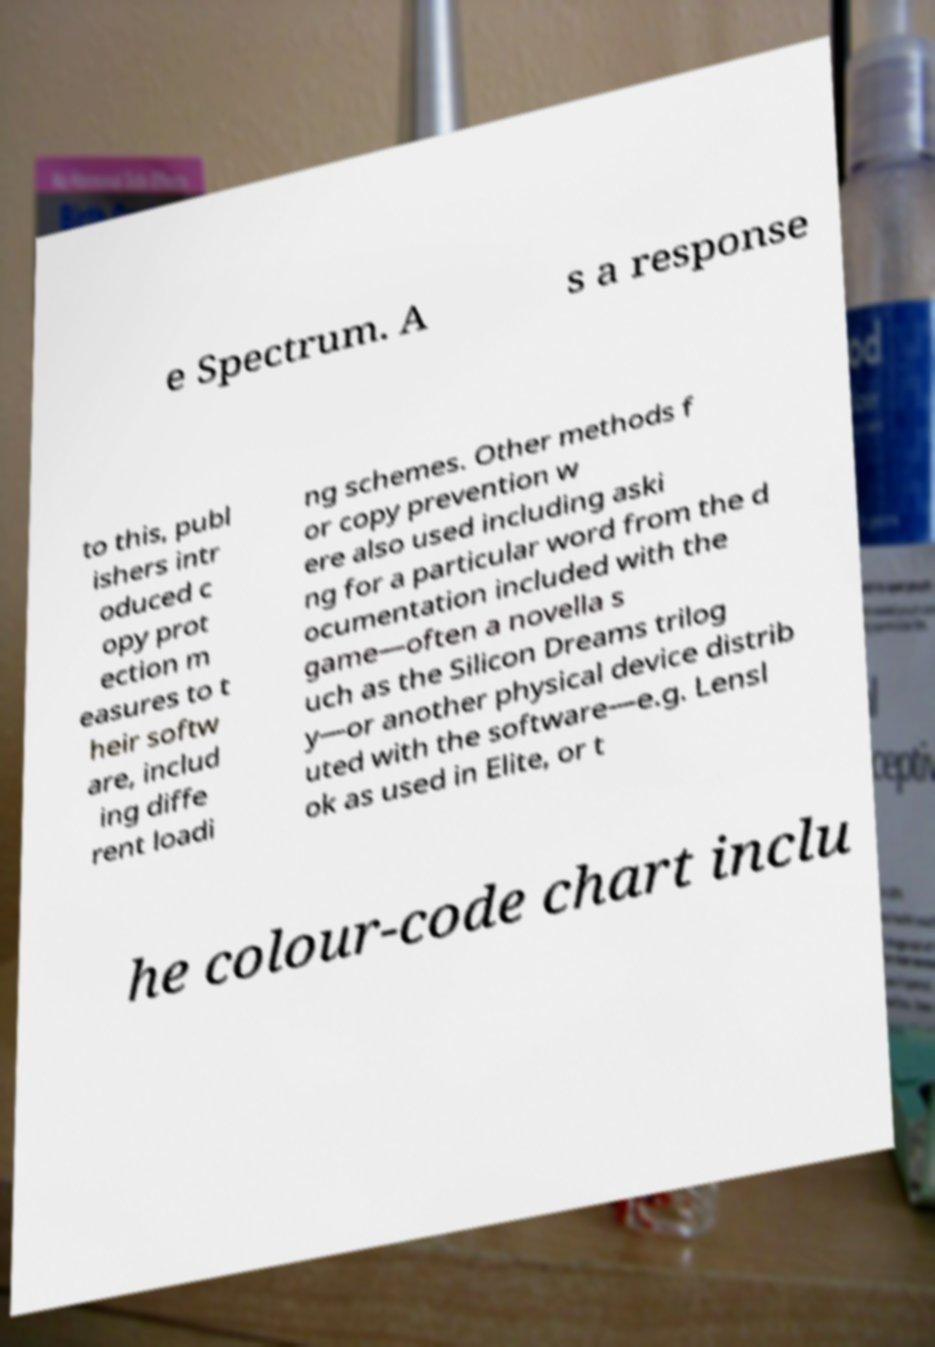Please read and relay the text visible in this image. What does it say? e Spectrum. A s a response to this, publ ishers intr oduced c opy prot ection m easures to t heir softw are, includ ing diffe rent loadi ng schemes. Other methods f or copy prevention w ere also used including aski ng for a particular word from the d ocumentation included with the game—often a novella s uch as the Silicon Dreams trilog y—or another physical device distrib uted with the software—e.g. Lensl ok as used in Elite, or t he colour-code chart inclu 